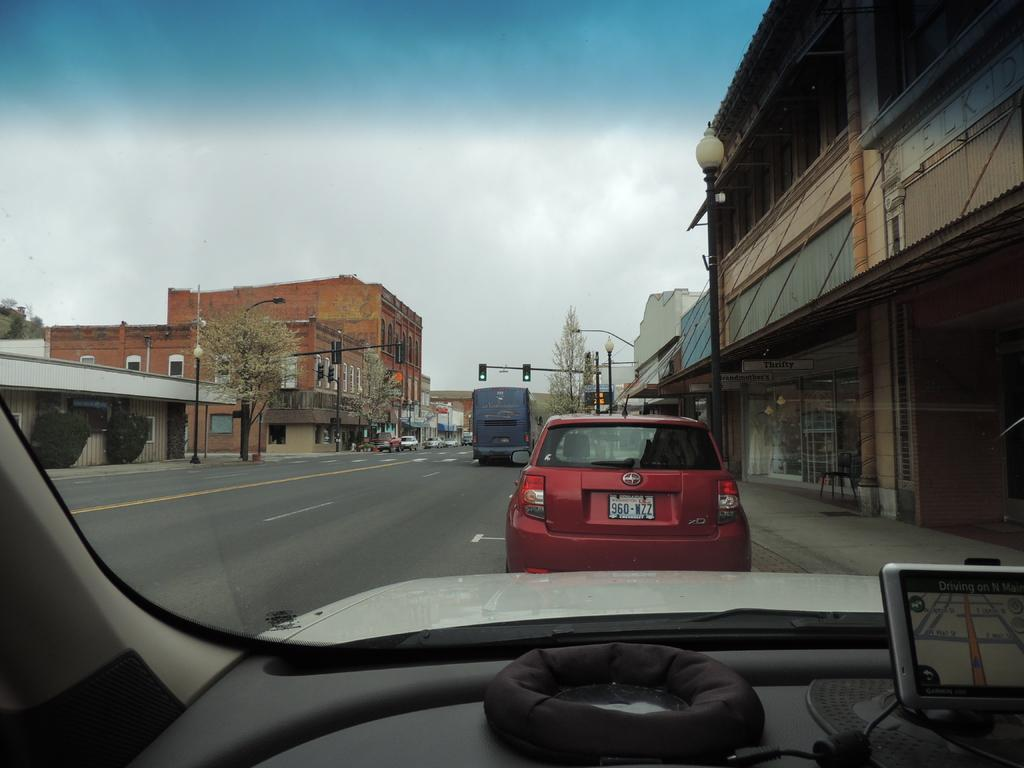What is the main feature of the image? There is a road in the image. What types of vehicles can be seen on the road? There are cars and a bus in the image. What structures are visible in the image? There are buildings in the image. What type of lighting is present in the image? There is a street light in the image. What type of vegetation is present in the image? There are trees and plants in front of the building in the image. What can be seen in the background of the image? The sky is visible in the background of the image. What type of fruit is hanging from the trees in the image? There is no fruit visible in the image; only trees and plants are present. Can you locate an orange in the image? There is no orange present in the image. 